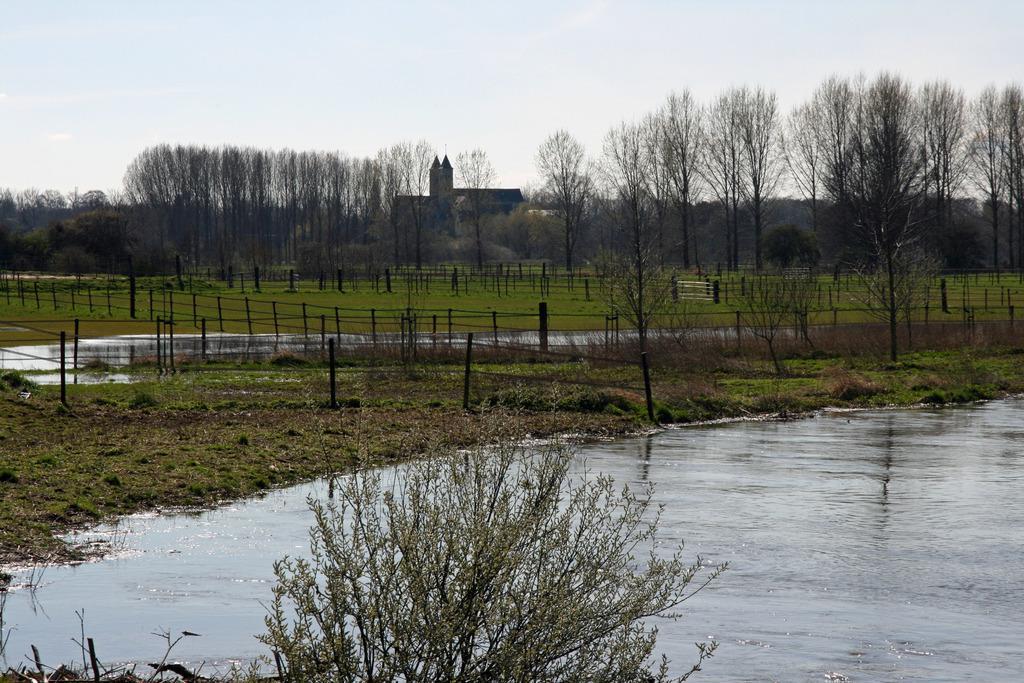Can you describe this image briefly? This is the picture of a place where we have a lake and around there are some trees, plants, grass, poles and some fencing to the side. 